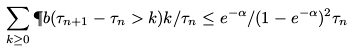<formula> <loc_0><loc_0><loc_500><loc_500>\sum _ { k \geq 0 } \P b ( \tau _ { n + 1 } - \tau _ { n } > k ) k / \tau _ { n } \leq e ^ { - \alpha } / ( 1 - e ^ { - \alpha } ) ^ { 2 } \tau _ { n }</formula> 